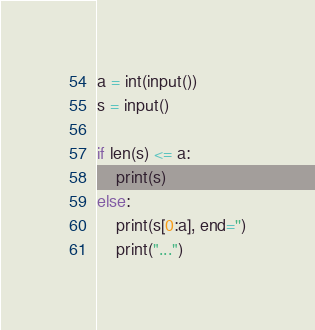Convert code to text. <code><loc_0><loc_0><loc_500><loc_500><_Python_>a = int(input())
s = input()

if len(s) <= a:
    print(s)
else:
    print(s[0:a], end='')
    print("...")</code> 